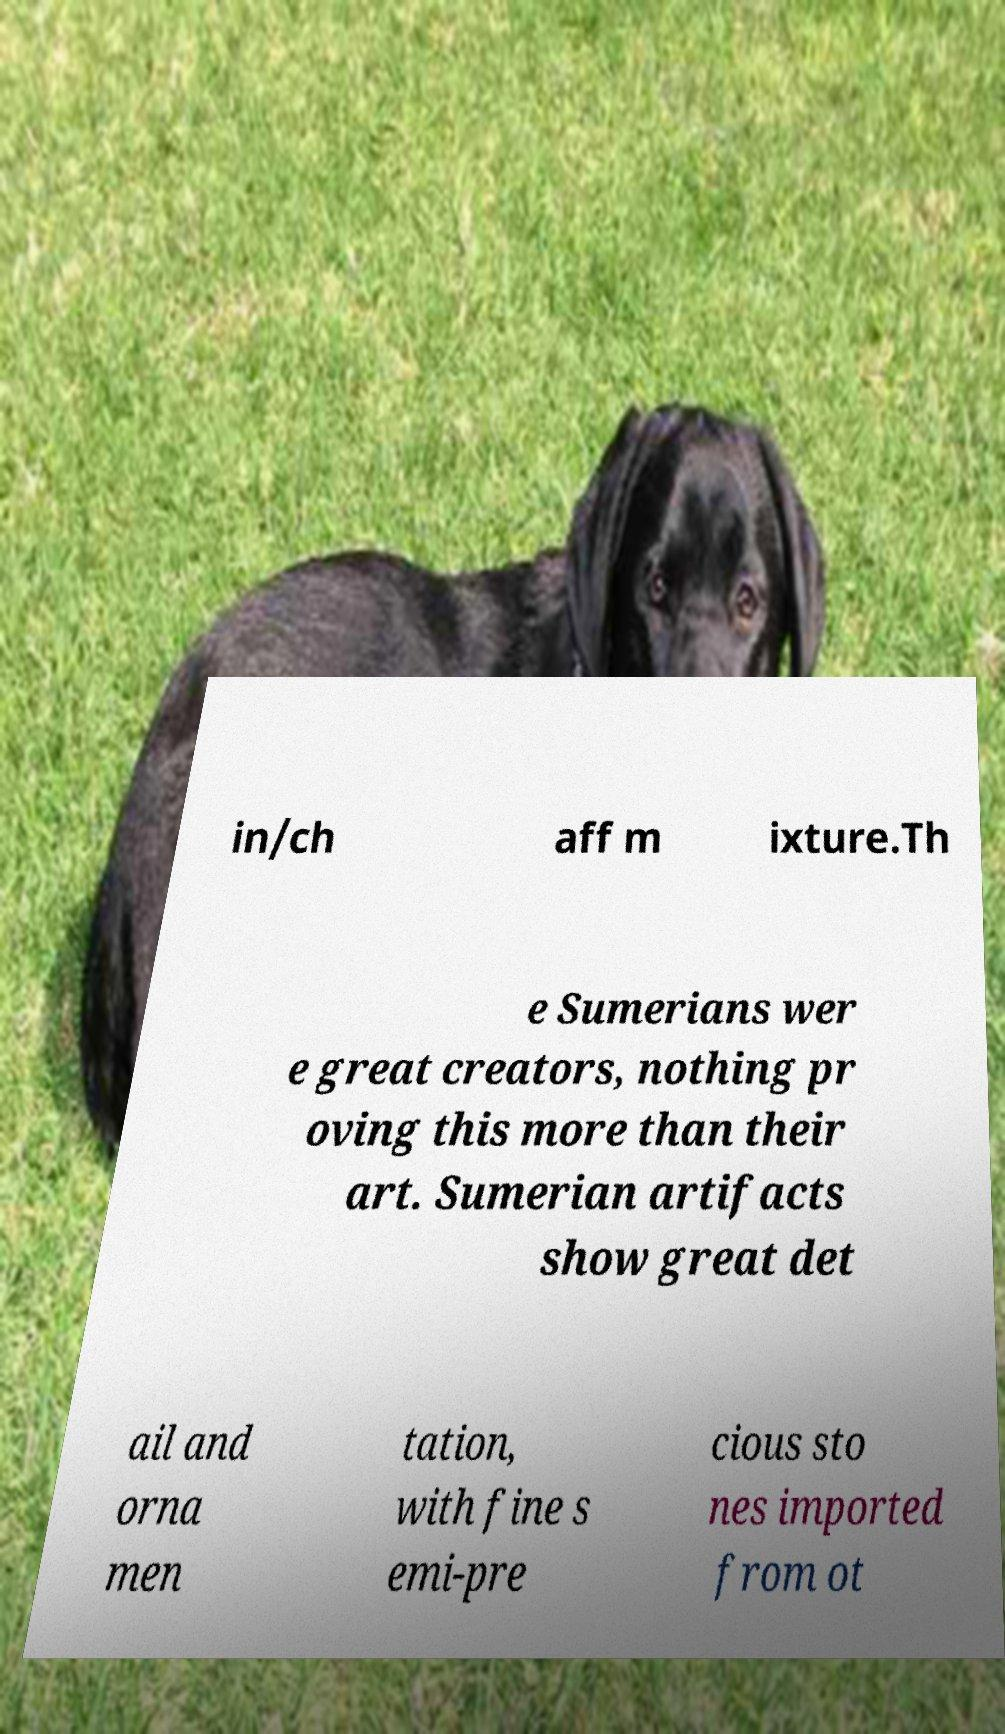I need the written content from this picture converted into text. Can you do that? in/ch aff m ixture.Th e Sumerians wer e great creators, nothing pr oving this more than their art. Sumerian artifacts show great det ail and orna men tation, with fine s emi-pre cious sto nes imported from ot 